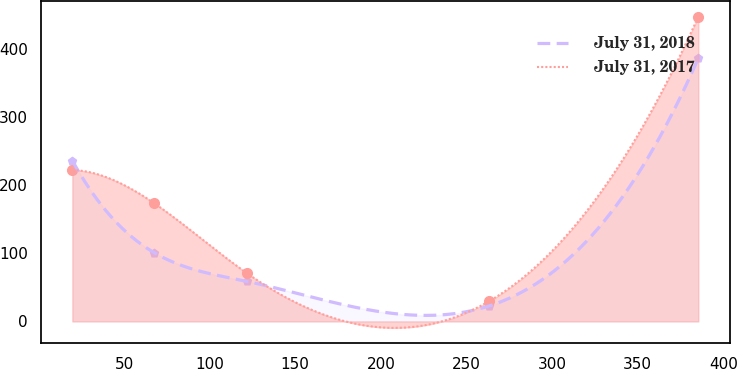Convert chart to OTSL. <chart><loc_0><loc_0><loc_500><loc_500><line_chart><ecel><fcel>July 31, 2018<fcel>July 31, 2017<nl><fcel>19.82<fcel>235.96<fcel>222.22<nl><fcel>67.59<fcel>100.92<fcel>173.48<nl><fcel>121.55<fcel>58.92<fcel>71.16<nl><fcel>263.04<fcel>22.55<fcel>29.36<nl><fcel>385.42<fcel>386.3<fcel>447.32<nl></chart> 